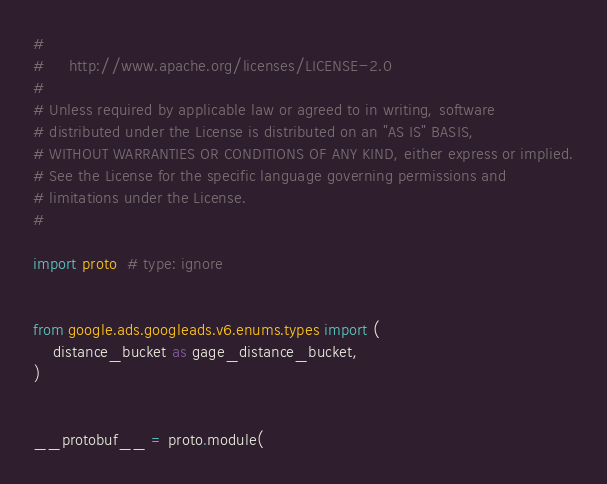<code> <loc_0><loc_0><loc_500><loc_500><_Python_>#
#     http://www.apache.org/licenses/LICENSE-2.0
#
# Unless required by applicable law or agreed to in writing, software
# distributed under the License is distributed on an "AS IS" BASIS,
# WITHOUT WARRANTIES OR CONDITIONS OF ANY KIND, either express or implied.
# See the License for the specific language governing permissions and
# limitations under the License.
#

import proto  # type: ignore


from google.ads.googleads.v6.enums.types import (
    distance_bucket as gage_distance_bucket,
)


__protobuf__ = proto.module(</code> 